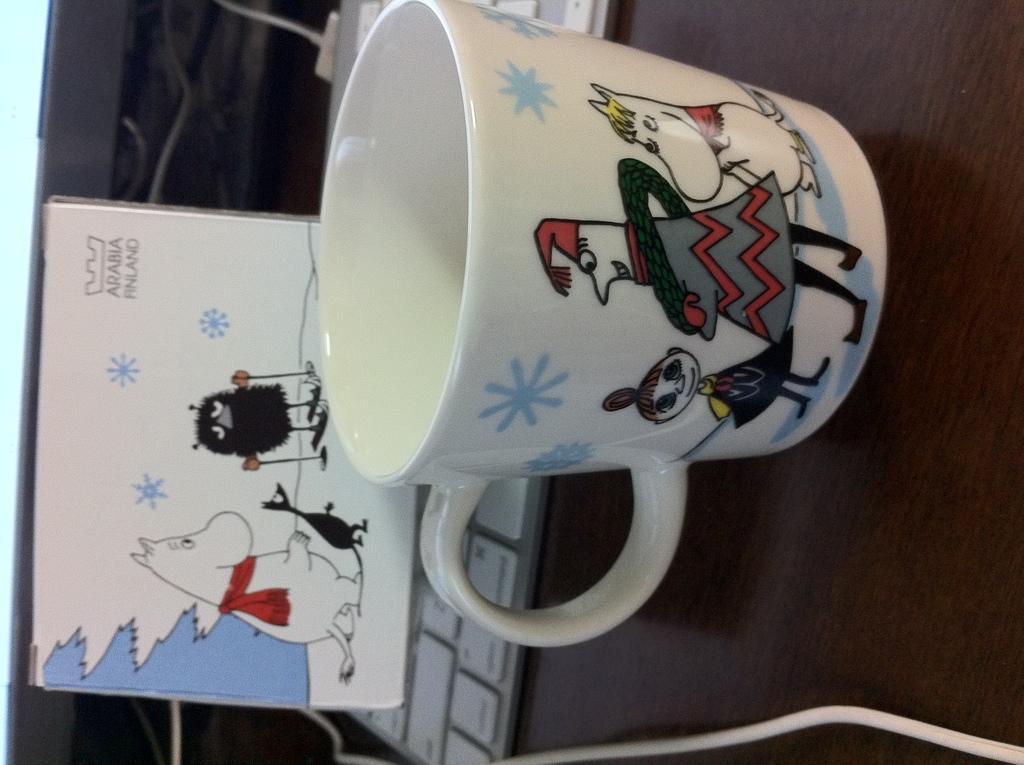Please provide a concise description of this image. In this image there is a keyboard, cup, car, cables and objects are on the wooden surface. We can see drawings on the cup and card.   